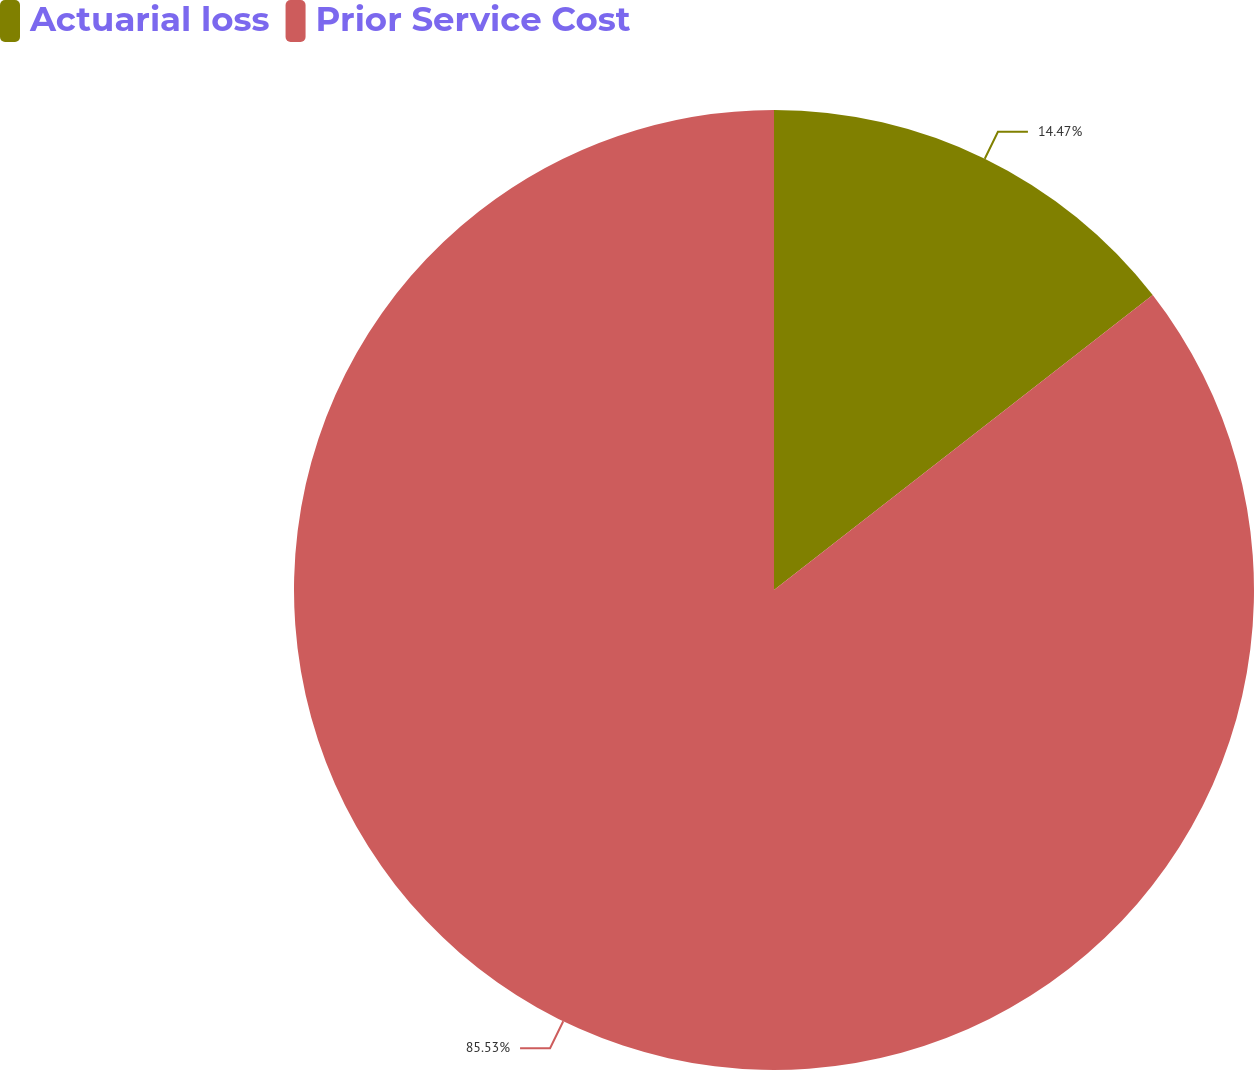Convert chart. <chart><loc_0><loc_0><loc_500><loc_500><pie_chart><fcel>Actuarial loss<fcel>Prior Service Cost<nl><fcel>14.47%<fcel>85.53%<nl></chart> 